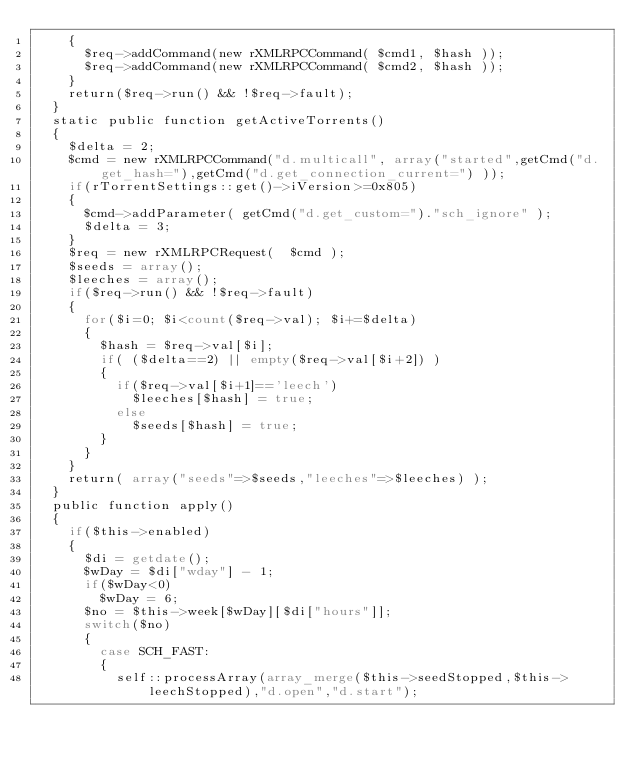<code> <loc_0><loc_0><loc_500><loc_500><_PHP_>		{
			$req->addCommand(new rXMLRPCCommand( $cmd1, $hash ));
			$req->addCommand(new rXMLRPCCommand( $cmd2, $hash ));
		}
		return($req->run() && !$req->fault);
	}
	static public function getActiveTorrents()
	{
		$delta = 2;
		$cmd = new rXMLRPCCommand("d.multicall", array("started",getCmd("d.get_hash="),getCmd("d.get_connection_current=") ));
		if(rTorrentSettings::get()->iVersion>=0x805)
		{
			$cmd->addParameter( getCmd("d.get_custom=")."sch_ignore" );
			$delta = 3;
		}
		$req = new rXMLRPCRequest(  $cmd );
		$seeds = array();
		$leeches = array();
		if($req->run() && !$req->fault)
		{
			for($i=0; $i<count($req->val); $i+=$delta)
			{
				$hash = $req->val[$i];
				if( ($delta==2) || empty($req->val[$i+2]) )
				{
					if($req->val[$i+1]=='leech')
						$leeches[$hash] = true;
					else
						$seeds[$hash] = true;
				}
			}
		}
		return( array("seeds"=>$seeds,"leeches"=>$leeches) );
	}
	public function apply()
	{
		if($this->enabled)
		{
			$di = getdate();
			$wDay = $di["wday"] - 1;
			if($wDay<0)
				$wDay = 6;
			$no = $this->week[$wDay][$di["hours"]];
			switch($no)
			{
				case SCH_FAST:
				{
					self::processArray(array_merge($this->seedStopped,$this->leechStopped),"d.open","d.start");</code> 